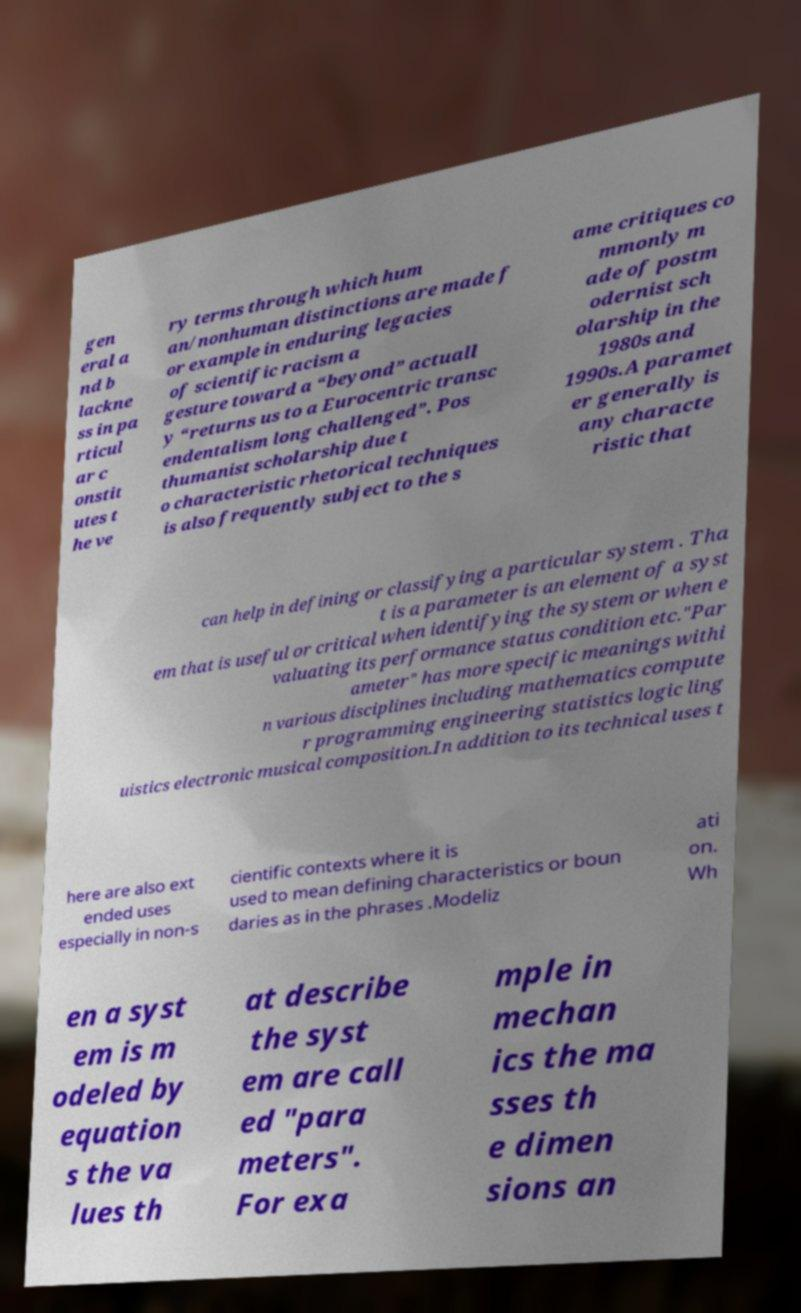Can you read and provide the text displayed in the image?This photo seems to have some interesting text. Can you extract and type it out for me? gen eral a nd b lackne ss in pa rticul ar c onstit utes t he ve ry terms through which hum an/nonhuman distinctions are made f or example in enduring legacies of scientific racism a gesture toward a “beyond” actuall y “returns us to a Eurocentric transc endentalism long challenged”. Pos thumanist scholarship due t o characteristic rhetorical techniques is also frequently subject to the s ame critiques co mmonly m ade of postm odernist sch olarship in the 1980s and 1990s.A paramet er generally is any characte ristic that can help in defining or classifying a particular system . Tha t is a parameter is an element of a syst em that is useful or critical when identifying the system or when e valuating its performance status condition etc."Par ameter" has more specific meanings withi n various disciplines including mathematics compute r programming engineering statistics logic ling uistics electronic musical composition.In addition to its technical uses t here are also ext ended uses especially in non-s cientific contexts where it is used to mean defining characteristics or boun daries as in the phrases .Modeliz ati on. Wh en a syst em is m odeled by equation s the va lues th at describe the syst em are call ed "para meters". For exa mple in mechan ics the ma sses th e dimen sions an 